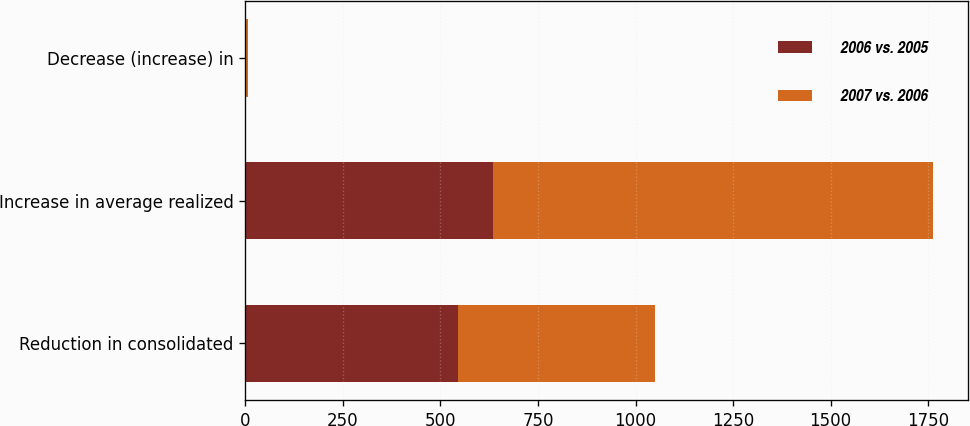Convert chart. <chart><loc_0><loc_0><loc_500><loc_500><stacked_bar_chart><ecel><fcel>Reduction in consolidated<fcel>Increase in average realized<fcel>Decrease (increase) in<nl><fcel>2006 vs. 2005<fcel>544<fcel>635<fcel>3<nl><fcel>2007 vs. 2006<fcel>506<fcel>1128<fcel>4<nl></chart> 